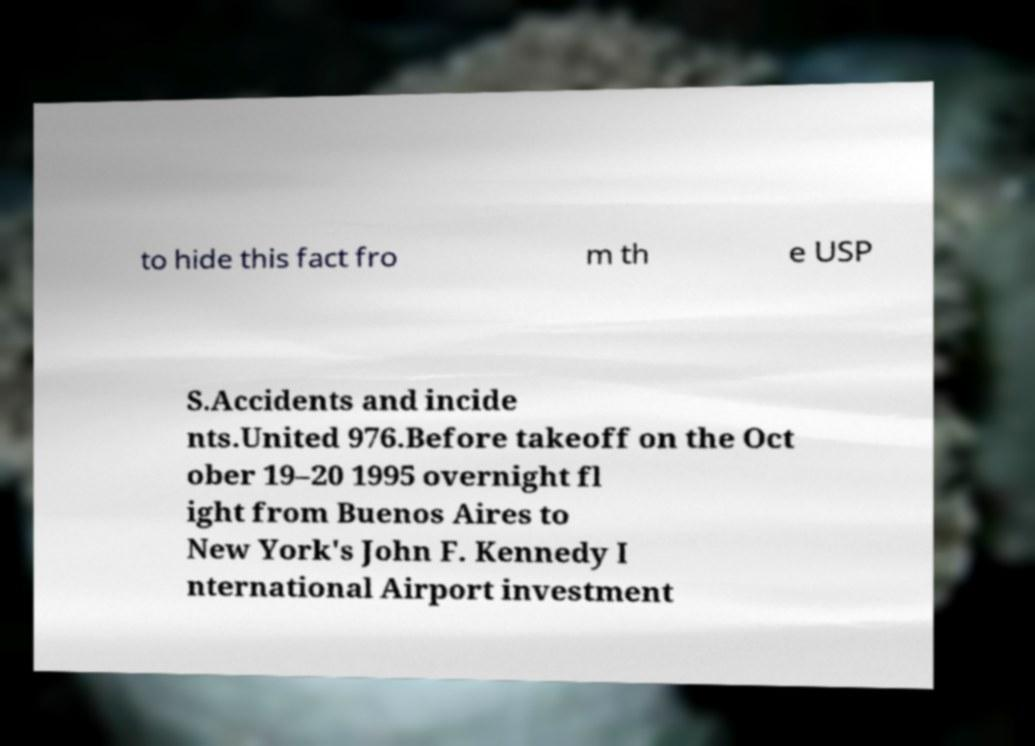For documentation purposes, I need the text within this image transcribed. Could you provide that? to hide this fact fro m th e USP S.Accidents and incide nts.United 976.Before takeoff on the Oct ober 19–20 1995 overnight fl ight from Buenos Aires to New York's John F. Kennedy I nternational Airport investment 